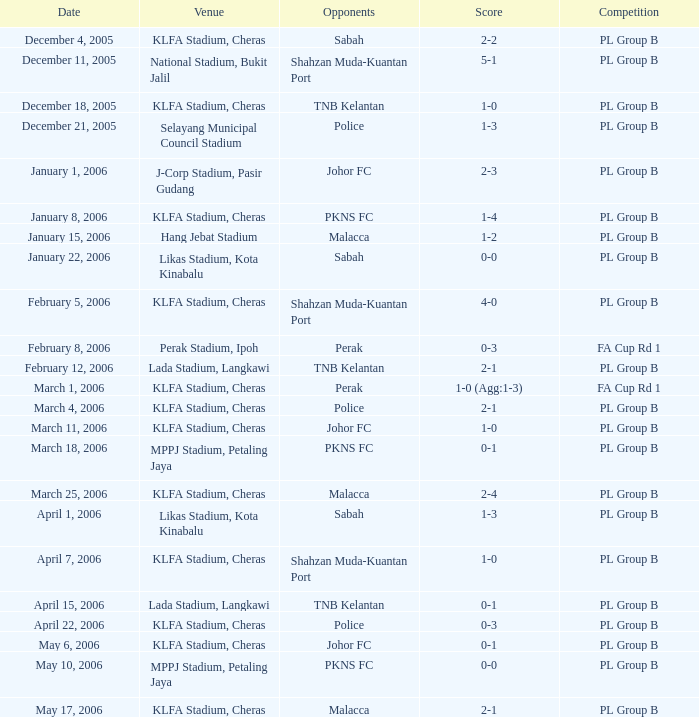Who competed on may 6, 2006? Johor FC. 